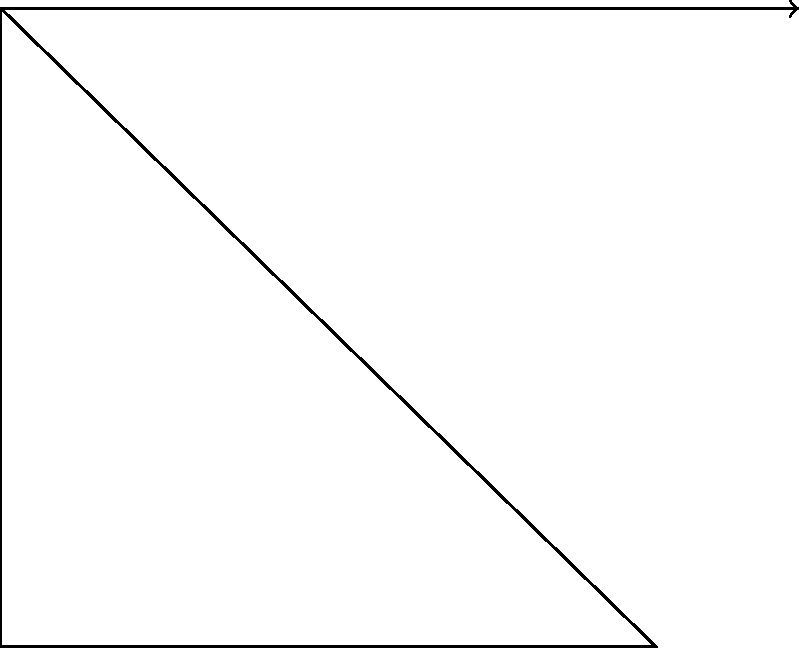As a professional swimming meet coordinator, you're tasked with optimizing the starting block angle for maximum dive distance. Given a starting block height of 0.8 meters and an initial velocity of 3 m/s, what is the optimal angle $\theta$ (in degrees) for the starting block to maximize the swimmer's dive distance? To find the optimal angle for maximum dive distance, we'll follow these steps:

1) The projectile motion equation for horizontal distance is:
   $$d = \frac{v^2 \sin(2\theta)}{g} + v\cos(\theta)\sqrt{\frac{2h}{g}}$$
   where $d$ is distance, $v$ is initial velocity, $\theta$ is launch angle, $g$ is gravitational acceleration, and $h$ is initial height.

2) To maximize $d$, we need to find the angle $\theta$ where $\frac{dd}{d\theta} = 0$.

3) Taking the derivative and setting it to zero:
   $$\frac{d}{d\theta}\left(\frac{v^2 \sin(2\theta)}{g} + v\cos(\theta)\sqrt{\frac{2h}{g}}\right) = 0$$

4) Simplifying:
   $$\frac{2v^2 \cos(2\theta)}{g} - v\sin(\theta)\sqrt{\frac{2h}{g}} = 0$$

5) For small heights relative to the projectile range, the optimal angle is close to 45°. We can verify this by substituting our values:
   $v = 3$ m/s, $g = 9.8$ m/s², $h = 0.8$ m

6) Solving numerically or graphically, we find that the equation is satisfied when $\theta \approx 42.3°$.

This angle is slightly less than 45° due to the non-zero starting height, which gives a slight advantage to a lower launch angle.
Answer: 42.3° 